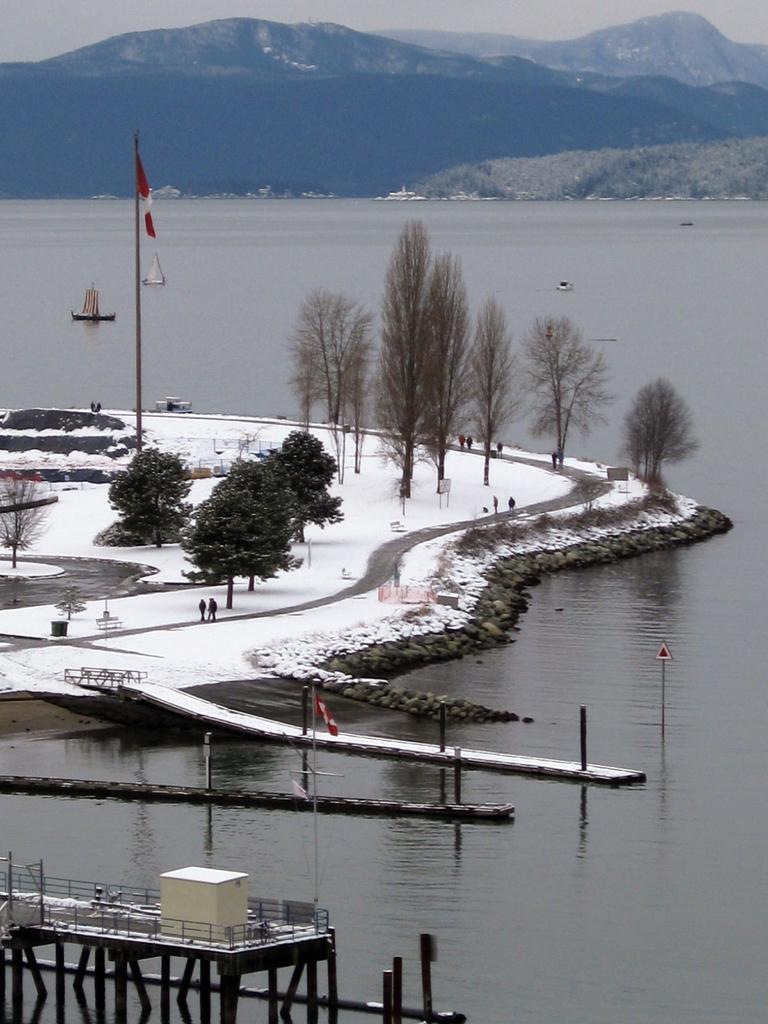Could you give a brief overview of what you see in this image? In this image I can see few trees in green color. I can also see few persons walking, snow in white color. Background I can see a flag in orange and white color and I can also see water, mountains, and sky in gray color. 